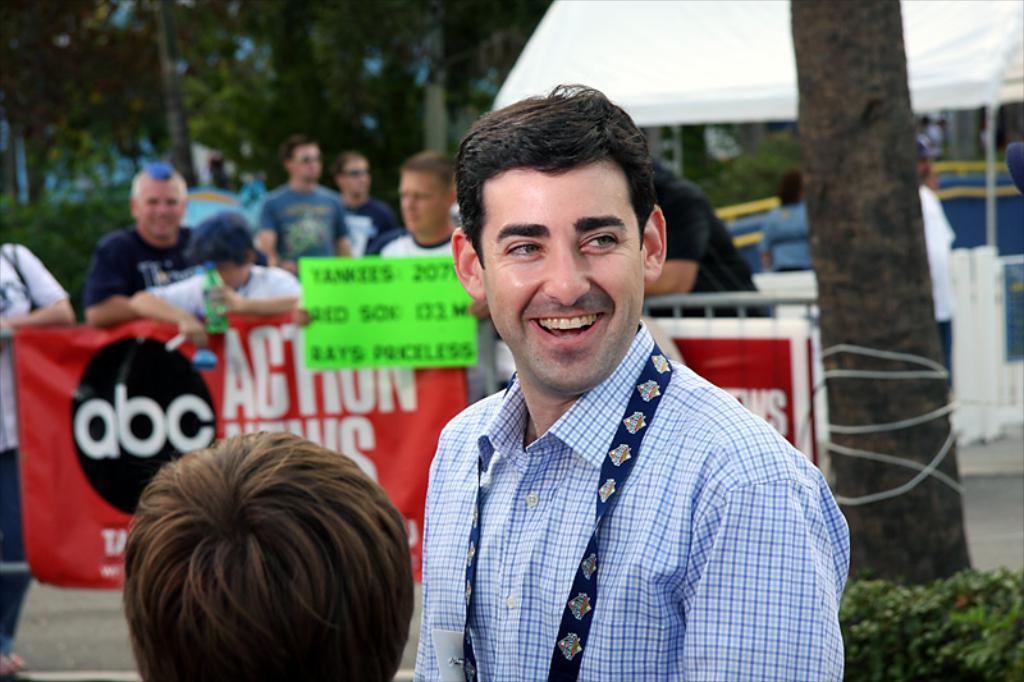How would you summarize this image in a sentence or two? In this image I can see a person standing and smiling. Back I can see few people and one person is holding bottle. I can see red banner and green board. I can see trees and white tent. 